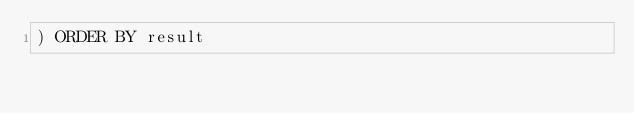Convert code to text. <code><loc_0><loc_0><loc_500><loc_500><_SQL_>) ORDER BY result
</code> 